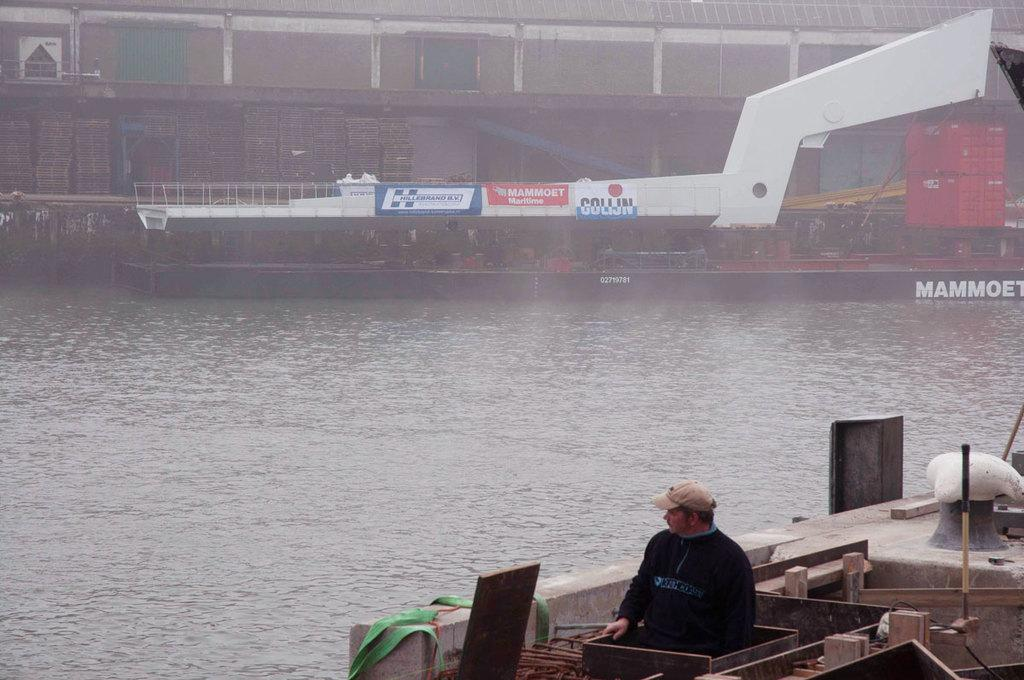What body of water is present in the image? There is a river in the image. What activity is taking place on the river? There is a person in a boat on the river. Can you describe the second boat in the river? There is another boat in the river with some things inside. What else can be seen in the image besides the river and boats? There is a building visible in the image. How many eyes can be seen on the person in the boat? There is no information about the person's eyes in the image, so we cannot determine the number of eyes. Is there a lift present in the image? There is no mention of a lift in the image, so we cannot confirm its presence. 